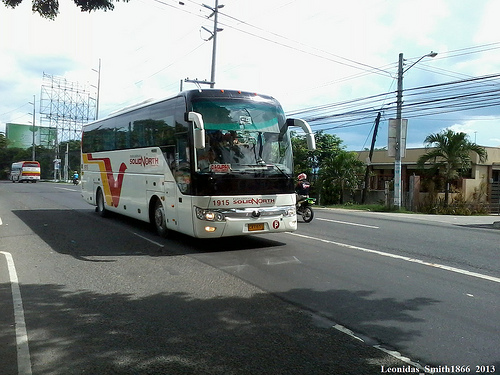Describe the main subject of the image. The main subject of the image is a bus on a street, with a motorcycle next to it. 